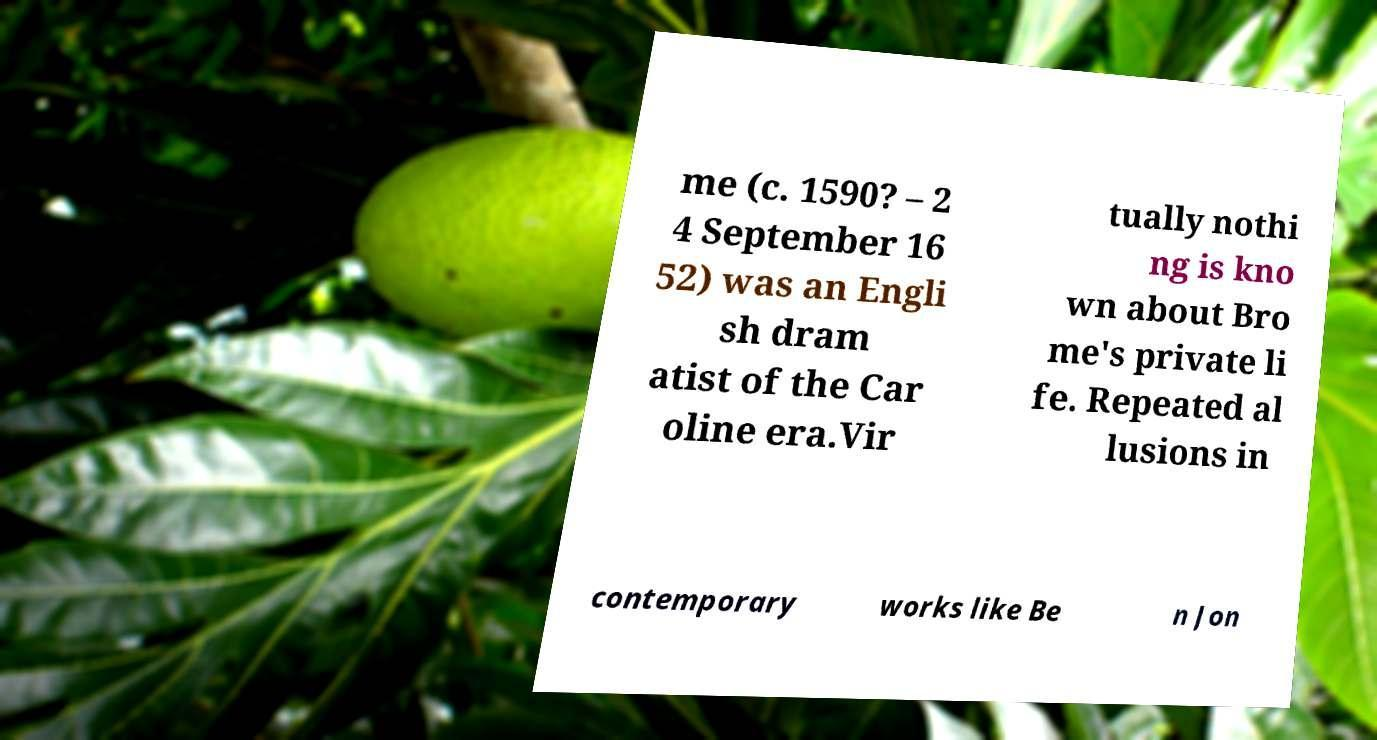Could you extract and type out the text from this image? me (c. 1590? – 2 4 September 16 52) was an Engli sh dram atist of the Car oline era.Vir tually nothi ng is kno wn about Bro me's private li fe. Repeated al lusions in contemporary works like Be n Jon 